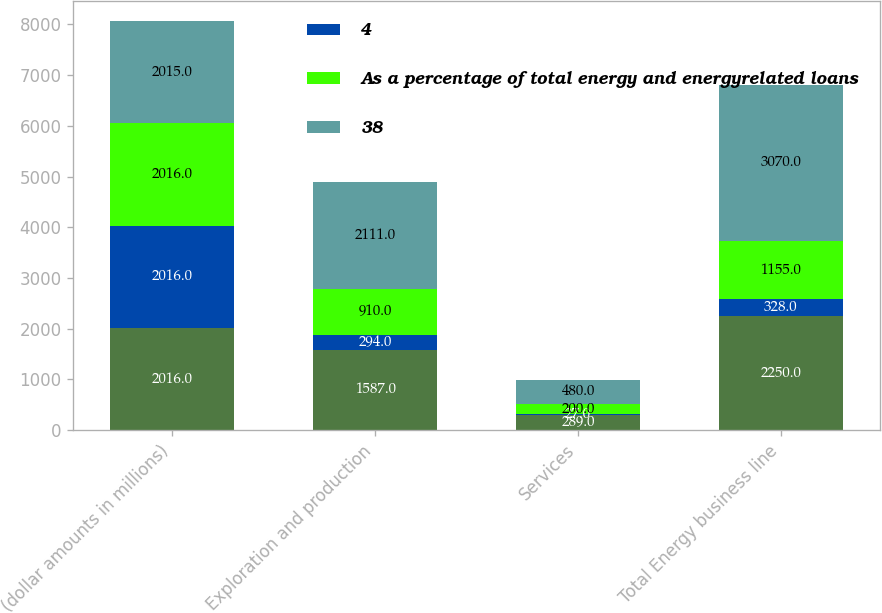Convert chart. <chart><loc_0><loc_0><loc_500><loc_500><stacked_bar_chart><ecel><fcel>(dollar amounts in millions)<fcel>Exploration and production<fcel>Services<fcel>Total Energy business line<nl><fcel>nan<fcel>2016<fcel>1587<fcel>289<fcel>2250<nl><fcel>4<fcel>2016<fcel>294<fcel>27<fcel>328<nl><fcel>As a percentage of total energy and energyrelated loans<fcel>2016<fcel>910<fcel>200<fcel>1155<nl><fcel>38<fcel>2015<fcel>2111<fcel>480<fcel>3070<nl></chart> 